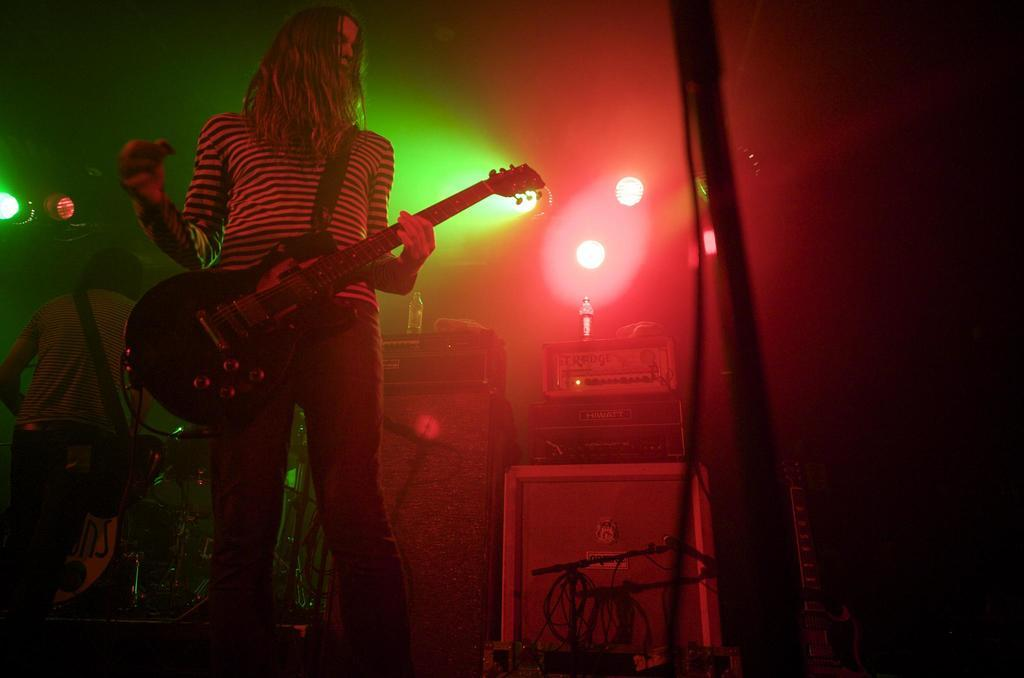What is the person in the foreground of the image holding? The person in the foreground of the image is holding a guitar. Can you describe the person in the background of the image? There is another person standing in the background of the image. What can be seen attached to the ceiling in the image? Lights are attached to the ceiling in the image. What type of stone is being used to make jam in the image? There is no stone or jam present in the image; it features a person holding a guitar and another person standing in the background. 